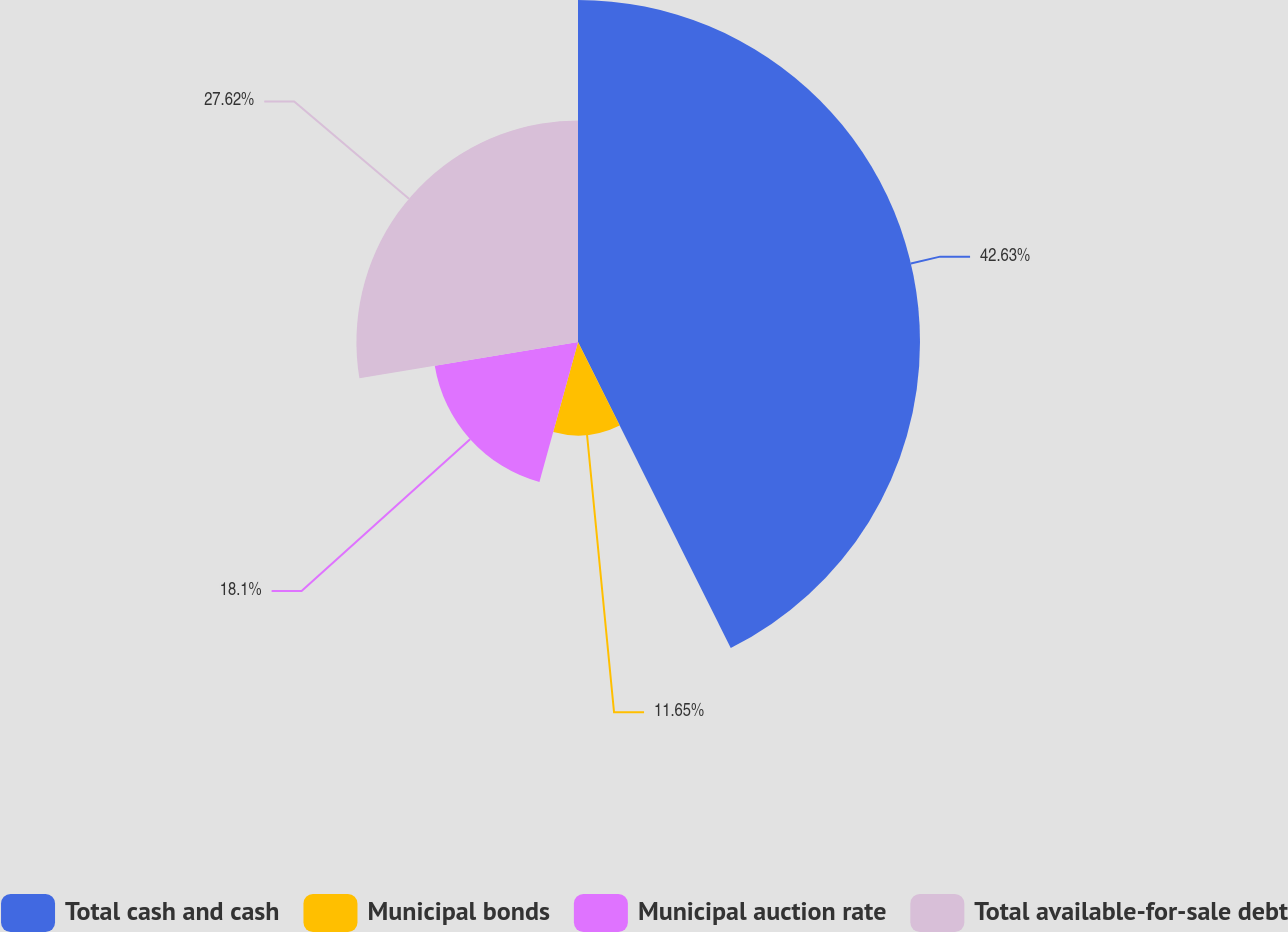<chart> <loc_0><loc_0><loc_500><loc_500><pie_chart><fcel>Total cash and cash<fcel>Municipal bonds<fcel>Municipal auction rate<fcel>Total available-for-sale debt<nl><fcel>42.63%<fcel>11.65%<fcel>18.1%<fcel>27.62%<nl></chart> 